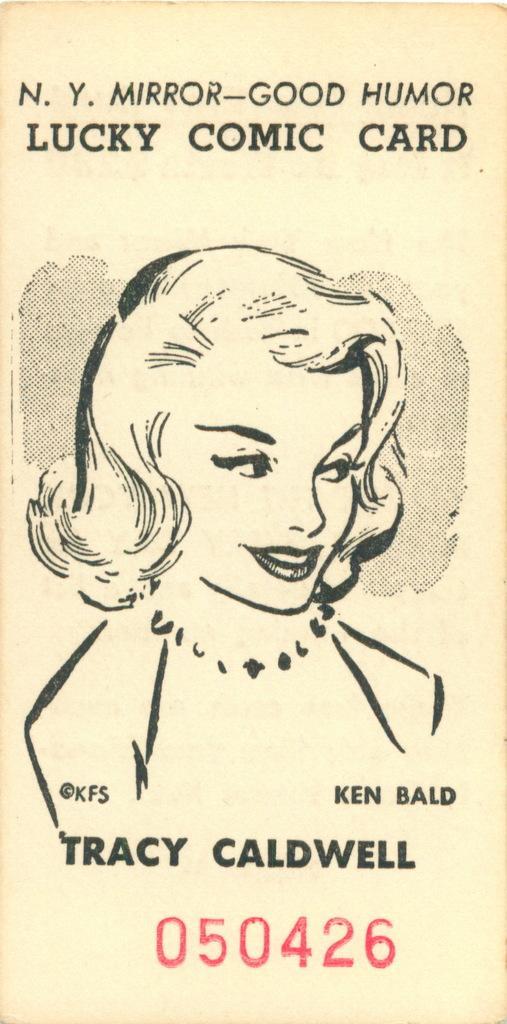In one or two sentences, can you explain what this image depicts? In this image we can able to a pamphlet which consists of a lady image, and we can able to see serial number here, we can able to see persons name here. 